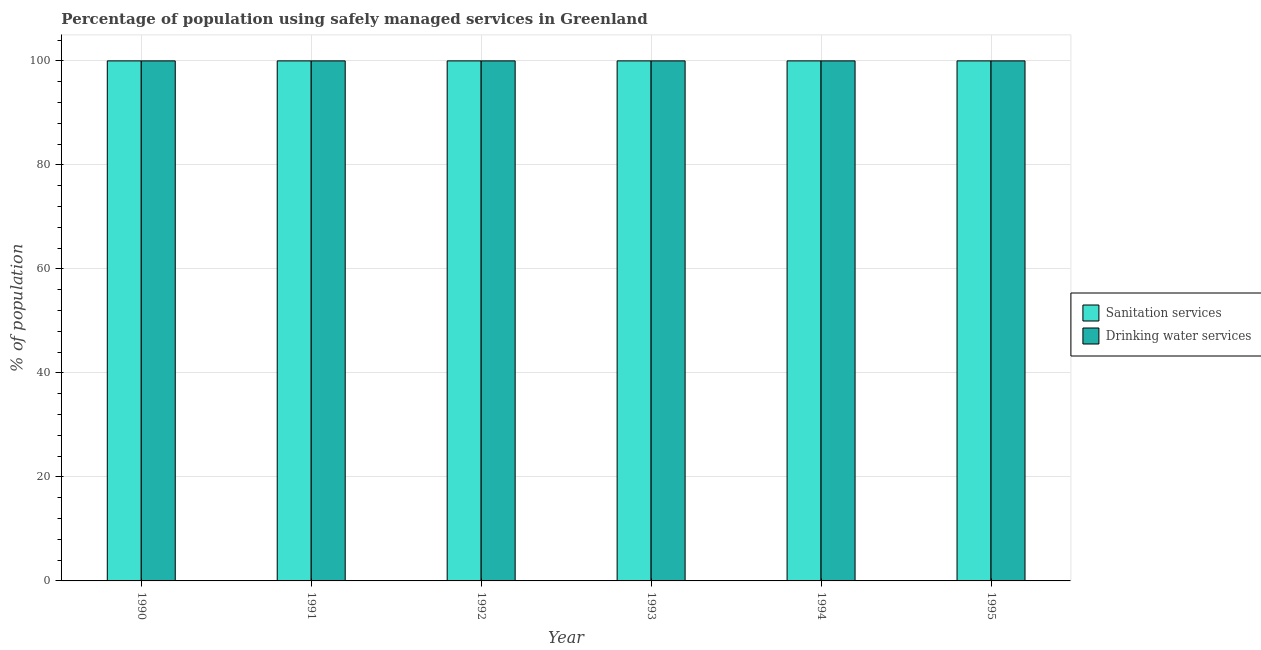How many different coloured bars are there?
Your response must be concise. 2. How many bars are there on the 3rd tick from the left?
Provide a short and direct response. 2. How many bars are there on the 5th tick from the right?
Offer a terse response. 2. What is the label of the 4th group of bars from the left?
Keep it short and to the point. 1993. What is the percentage of population who used sanitation services in 1990?
Ensure brevity in your answer.  100. Across all years, what is the maximum percentage of population who used sanitation services?
Provide a short and direct response. 100. Across all years, what is the minimum percentage of population who used sanitation services?
Give a very brief answer. 100. In which year was the percentage of population who used drinking water services minimum?
Offer a terse response. 1990. What is the total percentage of population who used sanitation services in the graph?
Make the answer very short. 600. What is the difference between the percentage of population who used sanitation services in 1991 and that in 1992?
Your answer should be very brief. 0. What is the difference between the percentage of population who used sanitation services in 1990 and the percentage of population who used drinking water services in 1992?
Make the answer very short. 0. What is the average percentage of population who used sanitation services per year?
Ensure brevity in your answer.  100. In the year 1995, what is the difference between the percentage of population who used drinking water services and percentage of population who used sanitation services?
Provide a short and direct response. 0. In how many years, is the percentage of population who used sanitation services greater than 64 %?
Make the answer very short. 6. Is the percentage of population who used drinking water services in 1990 less than that in 1994?
Your answer should be very brief. No. Is the difference between the percentage of population who used drinking water services in 1994 and 1995 greater than the difference between the percentage of population who used sanitation services in 1994 and 1995?
Your answer should be compact. No. What is the difference between the highest and the second highest percentage of population who used sanitation services?
Offer a very short reply. 0. In how many years, is the percentage of population who used drinking water services greater than the average percentage of population who used drinking water services taken over all years?
Your answer should be very brief. 0. Is the sum of the percentage of population who used sanitation services in 1990 and 1994 greater than the maximum percentage of population who used drinking water services across all years?
Give a very brief answer. Yes. What does the 1st bar from the left in 1990 represents?
Your answer should be very brief. Sanitation services. What does the 1st bar from the right in 1994 represents?
Keep it short and to the point. Drinking water services. How many bars are there?
Provide a succinct answer. 12. What is the difference between two consecutive major ticks on the Y-axis?
Ensure brevity in your answer.  20. Are the values on the major ticks of Y-axis written in scientific E-notation?
Give a very brief answer. No. Where does the legend appear in the graph?
Offer a terse response. Center right. How many legend labels are there?
Offer a very short reply. 2. What is the title of the graph?
Give a very brief answer. Percentage of population using safely managed services in Greenland. What is the label or title of the Y-axis?
Keep it short and to the point. % of population. What is the % of population of Drinking water services in 1993?
Offer a very short reply. 100. What is the % of population in Sanitation services in 1995?
Offer a very short reply. 100. What is the % of population in Drinking water services in 1995?
Offer a very short reply. 100. Across all years, what is the minimum % of population of Sanitation services?
Ensure brevity in your answer.  100. What is the total % of population of Sanitation services in the graph?
Keep it short and to the point. 600. What is the total % of population in Drinking water services in the graph?
Your answer should be very brief. 600. What is the difference between the % of population in Sanitation services in 1990 and that in 1992?
Make the answer very short. 0. What is the difference between the % of population of Sanitation services in 1990 and that in 1993?
Keep it short and to the point. 0. What is the difference between the % of population of Drinking water services in 1990 and that in 1993?
Your response must be concise. 0. What is the difference between the % of population in Sanitation services in 1990 and that in 1994?
Your response must be concise. 0. What is the difference between the % of population of Sanitation services in 1990 and that in 1995?
Provide a short and direct response. 0. What is the difference between the % of population in Sanitation services in 1991 and that in 1992?
Your response must be concise. 0. What is the difference between the % of population in Drinking water services in 1991 and that in 1992?
Give a very brief answer. 0. What is the difference between the % of population of Drinking water services in 1991 and that in 1993?
Make the answer very short. 0. What is the difference between the % of population of Drinking water services in 1992 and that in 1993?
Your answer should be compact. 0. What is the difference between the % of population in Sanitation services in 1992 and that in 1994?
Your response must be concise. 0. What is the difference between the % of population of Drinking water services in 1992 and that in 1994?
Ensure brevity in your answer.  0. What is the difference between the % of population in Sanitation services in 1992 and that in 1995?
Offer a terse response. 0. What is the difference between the % of population of Drinking water services in 1993 and that in 1995?
Offer a terse response. 0. What is the difference between the % of population in Sanitation services in 1994 and that in 1995?
Your answer should be compact. 0. What is the difference between the % of population in Sanitation services in 1990 and the % of population in Drinking water services in 1992?
Give a very brief answer. 0. What is the difference between the % of population in Sanitation services in 1990 and the % of population in Drinking water services in 1993?
Your answer should be compact. 0. What is the difference between the % of population of Sanitation services in 1990 and the % of population of Drinking water services in 1994?
Your answer should be compact. 0. What is the difference between the % of population in Sanitation services in 1990 and the % of population in Drinking water services in 1995?
Keep it short and to the point. 0. What is the difference between the % of population of Sanitation services in 1991 and the % of population of Drinking water services in 1993?
Provide a short and direct response. 0. What is the difference between the % of population of Sanitation services in 1991 and the % of population of Drinking water services in 1995?
Keep it short and to the point. 0. What is the difference between the % of population in Sanitation services in 1992 and the % of population in Drinking water services in 1994?
Offer a terse response. 0. What is the difference between the % of population of Sanitation services in 1993 and the % of population of Drinking water services in 1994?
Provide a succinct answer. 0. What is the difference between the % of population of Sanitation services in 1993 and the % of population of Drinking water services in 1995?
Provide a succinct answer. 0. What is the difference between the % of population in Sanitation services in 1994 and the % of population in Drinking water services in 1995?
Offer a terse response. 0. What is the average % of population of Sanitation services per year?
Make the answer very short. 100. In the year 1992, what is the difference between the % of population of Sanitation services and % of population of Drinking water services?
Make the answer very short. 0. In the year 1994, what is the difference between the % of population of Sanitation services and % of population of Drinking water services?
Provide a succinct answer. 0. In the year 1995, what is the difference between the % of population of Sanitation services and % of population of Drinking water services?
Provide a succinct answer. 0. What is the ratio of the % of population in Sanitation services in 1990 to that in 1991?
Make the answer very short. 1. What is the ratio of the % of population of Drinking water services in 1990 to that in 1991?
Give a very brief answer. 1. What is the ratio of the % of population in Sanitation services in 1990 to that in 1993?
Keep it short and to the point. 1. What is the ratio of the % of population of Sanitation services in 1990 to that in 1994?
Give a very brief answer. 1. What is the ratio of the % of population of Drinking water services in 1990 to that in 1994?
Give a very brief answer. 1. What is the ratio of the % of population of Drinking water services in 1990 to that in 1995?
Provide a succinct answer. 1. What is the ratio of the % of population of Sanitation services in 1991 to that in 1992?
Make the answer very short. 1. What is the ratio of the % of population of Drinking water services in 1991 to that in 1992?
Make the answer very short. 1. What is the ratio of the % of population of Drinking water services in 1991 to that in 1993?
Provide a succinct answer. 1. What is the ratio of the % of population in Sanitation services in 1991 to that in 1995?
Provide a succinct answer. 1. What is the ratio of the % of population of Sanitation services in 1992 to that in 1993?
Offer a terse response. 1. What is the ratio of the % of population of Sanitation services in 1992 to that in 1994?
Offer a terse response. 1. What is the ratio of the % of population of Drinking water services in 1992 to that in 1994?
Offer a very short reply. 1. What is the ratio of the % of population of Sanitation services in 1992 to that in 1995?
Keep it short and to the point. 1. What is the ratio of the % of population in Drinking water services in 1992 to that in 1995?
Your answer should be very brief. 1. What is the ratio of the % of population in Drinking water services in 1993 to that in 1994?
Offer a terse response. 1. What is the ratio of the % of population in Drinking water services in 1993 to that in 1995?
Give a very brief answer. 1. What is the difference between the highest and the second highest % of population in Sanitation services?
Offer a very short reply. 0. 